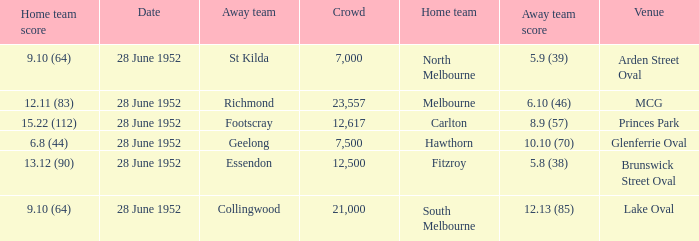What is the away team when north melbourne is at home? St Kilda. 